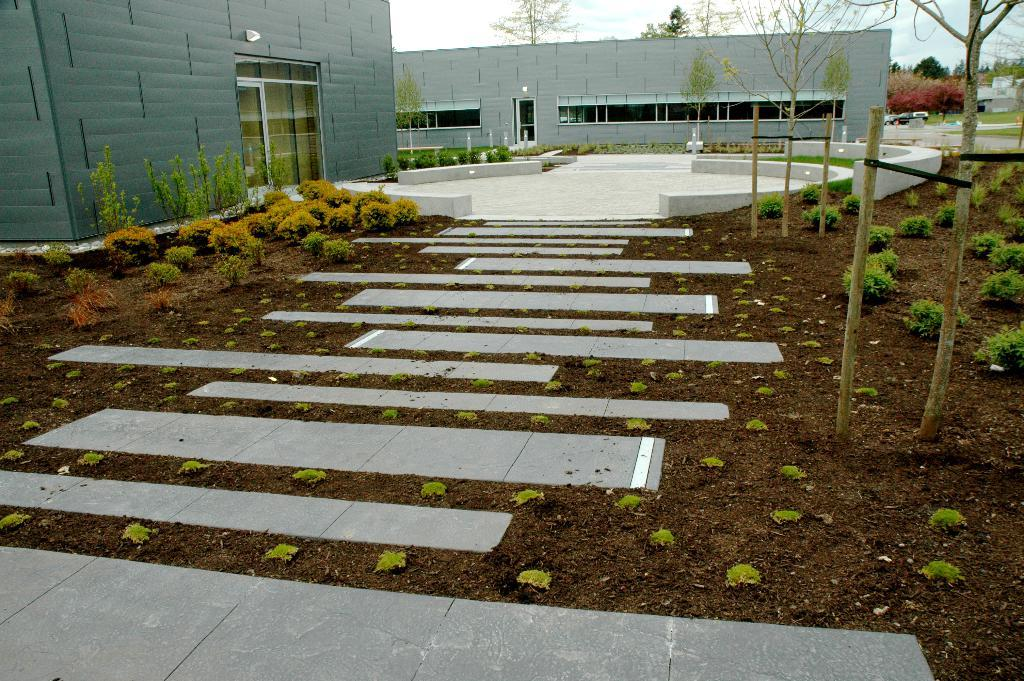What is present on the path in the image? There are plants on the path in the image. What can be seen in the distance behind the path? There are buildings and trees in the background of the image. Where is the fireman using the iron in the image? There is no fireman or iron present in the image. 